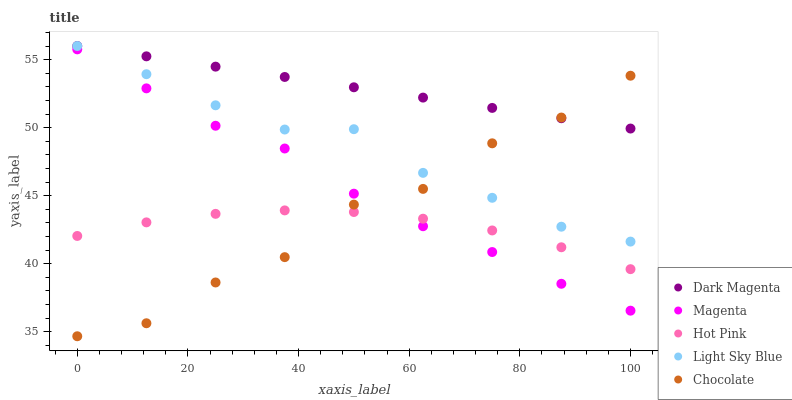Does Hot Pink have the minimum area under the curve?
Answer yes or no. Yes. Does Dark Magenta have the maximum area under the curve?
Answer yes or no. Yes. Does Dark Magenta have the minimum area under the curve?
Answer yes or no. No. Does Hot Pink have the maximum area under the curve?
Answer yes or no. No. Is Dark Magenta the smoothest?
Answer yes or no. Yes. Is Chocolate the roughest?
Answer yes or no. Yes. Is Hot Pink the smoothest?
Answer yes or no. No. Is Hot Pink the roughest?
Answer yes or no. No. Does Chocolate have the lowest value?
Answer yes or no. Yes. Does Hot Pink have the lowest value?
Answer yes or no. No. Does Light Sky Blue have the highest value?
Answer yes or no. Yes. Does Hot Pink have the highest value?
Answer yes or no. No. Is Hot Pink less than Light Sky Blue?
Answer yes or no. Yes. Is Dark Magenta greater than Magenta?
Answer yes or no. Yes. Does Dark Magenta intersect Chocolate?
Answer yes or no. Yes. Is Dark Magenta less than Chocolate?
Answer yes or no. No. Is Dark Magenta greater than Chocolate?
Answer yes or no. No. Does Hot Pink intersect Light Sky Blue?
Answer yes or no. No. 